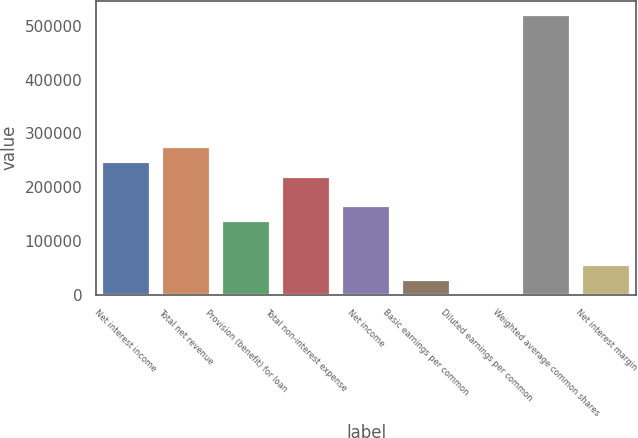Convert chart. <chart><loc_0><loc_0><loc_500><loc_500><bar_chart><fcel>Net interest income<fcel>Total net revenue<fcel>Provision (benefit) for loan<fcel>Total non-interest expense<fcel>Net income<fcel>Basic earnings per common<fcel>Diluted earnings per common<fcel>Weighted average common shares<fcel>Net interest margin<nl><fcel>246917<fcel>274352<fcel>137177<fcel>219482<fcel>164612<fcel>27437.1<fcel>2.15<fcel>521267<fcel>54872.1<nl></chart> 